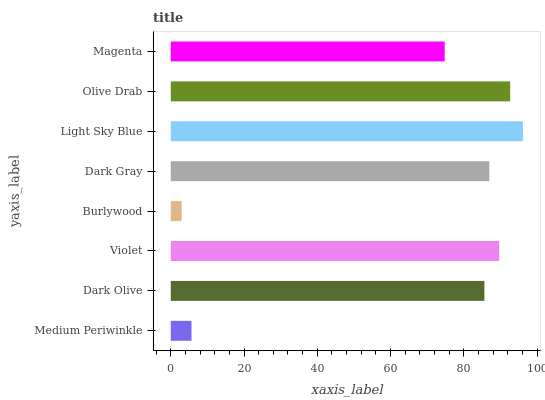Is Burlywood the minimum?
Answer yes or no. Yes. Is Light Sky Blue the maximum?
Answer yes or no. Yes. Is Dark Olive the minimum?
Answer yes or no. No. Is Dark Olive the maximum?
Answer yes or no. No. Is Dark Olive greater than Medium Periwinkle?
Answer yes or no. Yes. Is Medium Periwinkle less than Dark Olive?
Answer yes or no. Yes. Is Medium Periwinkle greater than Dark Olive?
Answer yes or no. No. Is Dark Olive less than Medium Periwinkle?
Answer yes or no. No. Is Dark Gray the high median?
Answer yes or no. Yes. Is Dark Olive the low median?
Answer yes or no. Yes. Is Dark Olive the high median?
Answer yes or no. No. Is Burlywood the low median?
Answer yes or no. No. 